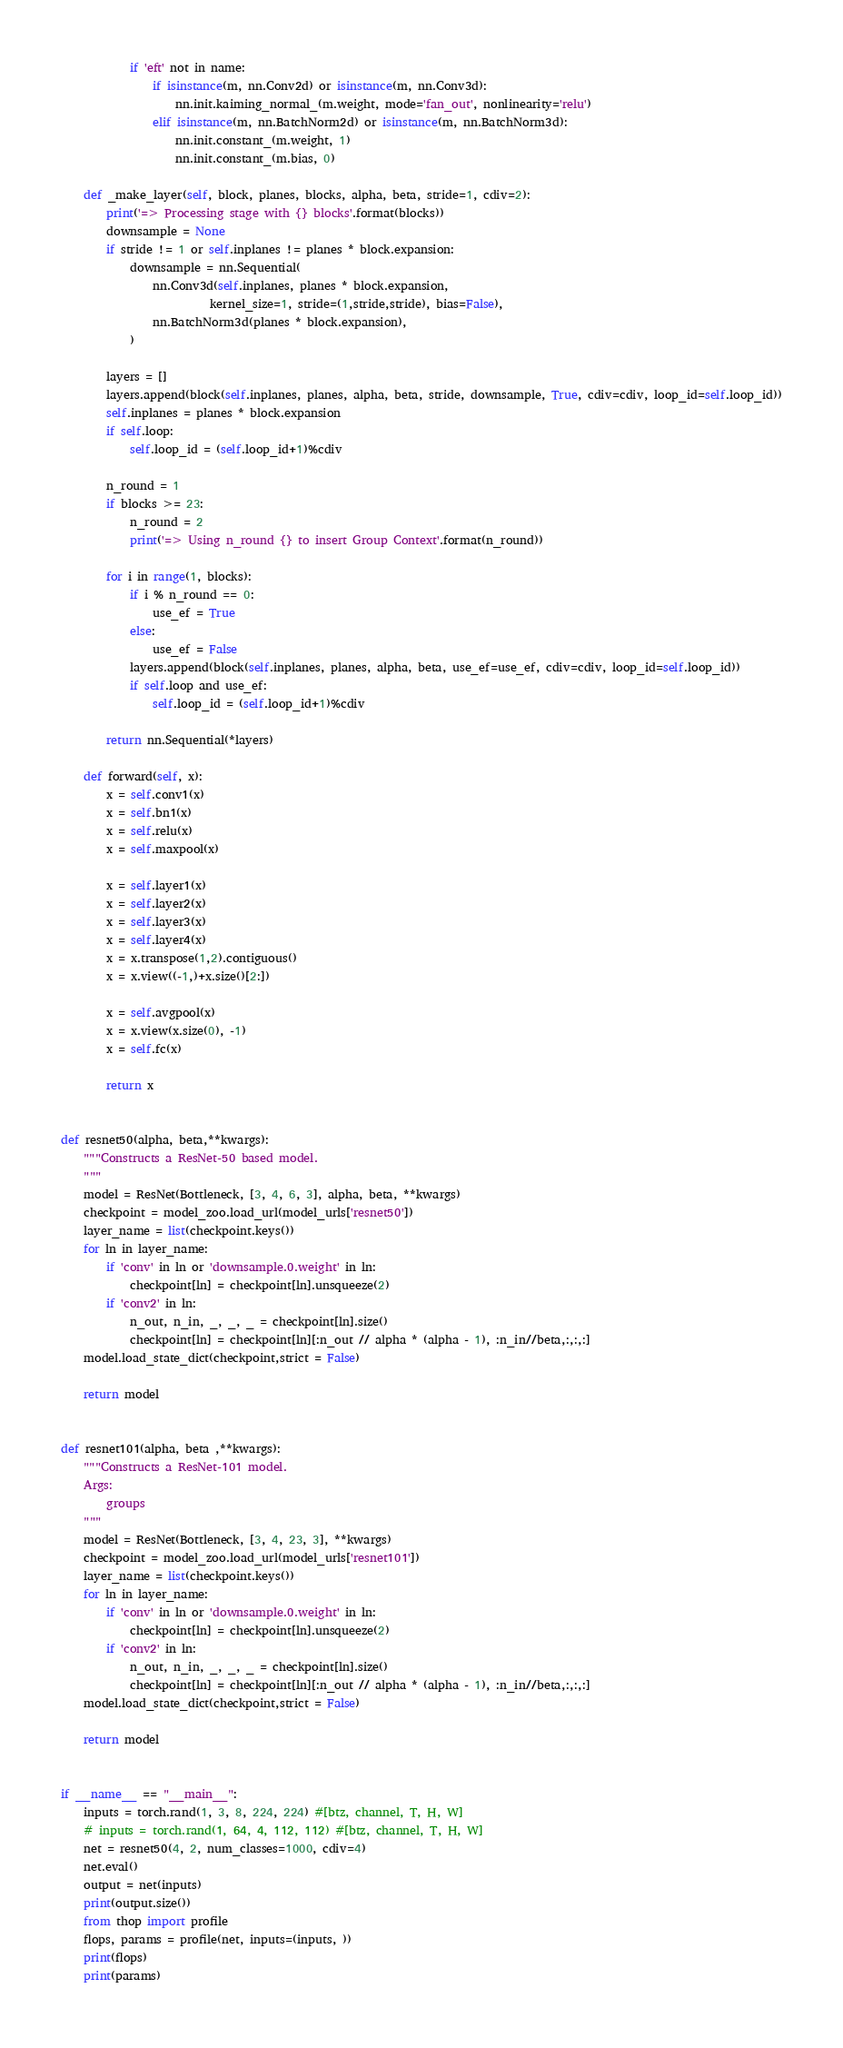<code> <loc_0><loc_0><loc_500><loc_500><_Python_>			if 'eft' not in name:
				if isinstance(m, nn.Conv2d) or isinstance(m, nn.Conv3d):
					nn.init.kaiming_normal_(m.weight, mode='fan_out', nonlinearity='relu')
				elif isinstance(m, nn.BatchNorm2d) or isinstance(m, nn.BatchNorm3d):
					nn.init.constant_(m.weight, 1)
					nn.init.constant_(m.bias, 0)

	def _make_layer(self, block, planes, blocks, alpha, beta, stride=1, cdiv=2):
		print('=> Processing stage with {} blocks'.format(blocks))
		downsample = None
		if stride != 1 or self.inplanes != planes * block.expansion:
			downsample = nn.Sequential(
				nn.Conv3d(self.inplanes, planes * block.expansion,
						  kernel_size=1, stride=(1,stride,stride), bias=False),
				nn.BatchNorm3d(planes * block.expansion),
			)

		layers = []
		layers.append(block(self.inplanes, planes, alpha, beta, stride, downsample, True, cdiv=cdiv, loop_id=self.loop_id))
		self.inplanes = planes * block.expansion
		if self.loop:
			self.loop_id = (self.loop_id+1)%cdiv

		n_round = 1
		if blocks >= 23:
			n_round = 2
			print('=> Using n_round {} to insert Group Context'.format(n_round))

		for i in range(1, blocks):
			if i % n_round == 0:
				use_ef = True
			else:
				use_ef = False
			layers.append(block(self.inplanes, planes, alpha, beta, use_ef=use_ef, cdiv=cdiv, loop_id=self.loop_id))
			if self.loop and use_ef:
				self.loop_id = (self.loop_id+1)%cdiv

		return nn.Sequential(*layers)

	def forward(self, x):
		x = self.conv1(x)
		x = self.bn1(x)
		x = self.relu(x)
		x = self.maxpool(x)

		x = self.layer1(x)
		x = self.layer2(x)
		x = self.layer3(x)
		x = self.layer4(x)
		x = x.transpose(1,2).contiguous()
		x = x.view((-1,)+x.size()[2:])

		x = self.avgpool(x)
		x = x.view(x.size(0), -1)
		x = self.fc(x)

		return x


def resnet50(alpha, beta,**kwargs):
	"""Constructs a ResNet-50 based model.
	"""
	model = ResNet(Bottleneck, [3, 4, 6, 3], alpha, beta, **kwargs)
	checkpoint = model_zoo.load_url(model_urls['resnet50'])
	layer_name = list(checkpoint.keys())
	for ln in layer_name:
		if 'conv' in ln or 'downsample.0.weight' in ln:
			checkpoint[ln] = checkpoint[ln].unsqueeze(2)
		if 'conv2' in ln:
			n_out, n_in, _, _, _ = checkpoint[ln].size()
			checkpoint[ln] = checkpoint[ln][:n_out // alpha * (alpha - 1), :n_in//beta,:,:,:]
	model.load_state_dict(checkpoint,strict = False)

	return model


def resnet101(alpha, beta ,**kwargs):
	"""Constructs a ResNet-101 model.
	Args:
		groups
	"""
	model = ResNet(Bottleneck, [3, 4, 23, 3], **kwargs)
	checkpoint = model_zoo.load_url(model_urls['resnet101'])
	layer_name = list(checkpoint.keys())
	for ln in layer_name:
		if 'conv' in ln or 'downsample.0.weight' in ln:
			checkpoint[ln] = checkpoint[ln].unsqueeze(2)
		if 'conv2' in ln:
			n_out, n_in, _, _, _ = checkpoint[ln].size()
			checkpoint[ln] = checkpoint[ln][:n_out // alpha * (alpha - 1), :n_in//beta,:,:,:]
	model.load_state_dict(checkpoint,strict = False)

	return model


if __name__ == "__main__":
	inputs = torch.rand(1, 3, 8, 224, 224) #[btz, channel, T, H, W]
	# inputs = torch.rand(1, 64, 4, 112, 112) #[btz, channel, T, H, W]
	net = resnet50(4, 2, num_classes=1000, cdiv=4)
	net.eval()
	output = net(inputs)
	print(output.size())
	from thop import profile
	flops, params = profile(net, inputs=(inputs, ))
	print(flops)
	print(params)
</code> 